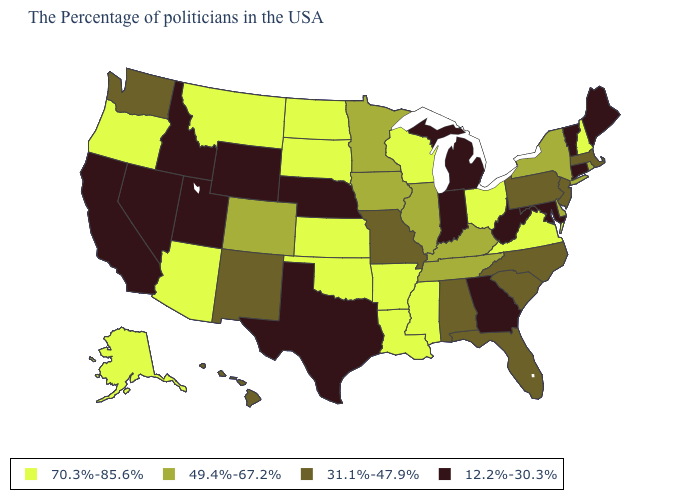Among the states that border Wyoming , which have the highest value?
Answer briefly. South Dakota, Montana. Does Wyoming have the lowest value in the West?
Short answer required. Yes. What is the value of Maryland?
Keep it brief. 12.2%-30.3%. What is the value of Ohio?
Write a very short answer. 70.3%-85.6%. What is the lowest value in the USA?
Keep it brief. 12.2%-30.3%. Name the states that have a value in the range 70.3%-85.6%?
Answer briefly. New Hampshire, Virginia, Ohio, Wisconsin, Mississippi, Louisiana, Arkansas, Kansas, Oklahoma, South Dakota, North Dakota, Montana, Arizona, Oregon, Alaska. What is the highest value in the USA?
Write a very short answer. 70.3%-85.6%. Name the states that have a value in the range 70.3%-85.6%?
Keep it brief. New Hampshire, Virginia, Ohio, Wisconsin, Mississippi, Louisiana, Arkansas, Kansas, Oklahoma, South Dakota, North Dakota, Montana, Arizona, Oregon, Alaska. What is the value of Vermont?
Keep it brief. 12.2%-30.3%. Name the states that have a value in the range 49.4%-67.2%?
Write a very short answer. Rhode Island, New York, Delaware, Kentucky, Tennessee, Illinois, Minnesota, Iowa, Colorado. Name the states that have a value in the range 12.2%-30.3%?
Quick response, please. Maine, Vermont, Connecticut, Maryland, West Virginia, Georgia, Michigan, Indiana, Nebraska, Texas, Wyoming, Utah, Idaho, Nevada, California. What is the lowest value in the South?
Answer briefly. 12.2%-30.3%. What is the lowest value in the MidWest?
Short answer required. 12.2%-30.3%. Name the states that have a value in the range 31.1%-47.9%?
Quick response, please. Massachusetts, New Jersey, Pennsylvania, North Carolina, South Carolina, Florida, Alabama, Missouri, New Mexico, Washington, Hawaii. 